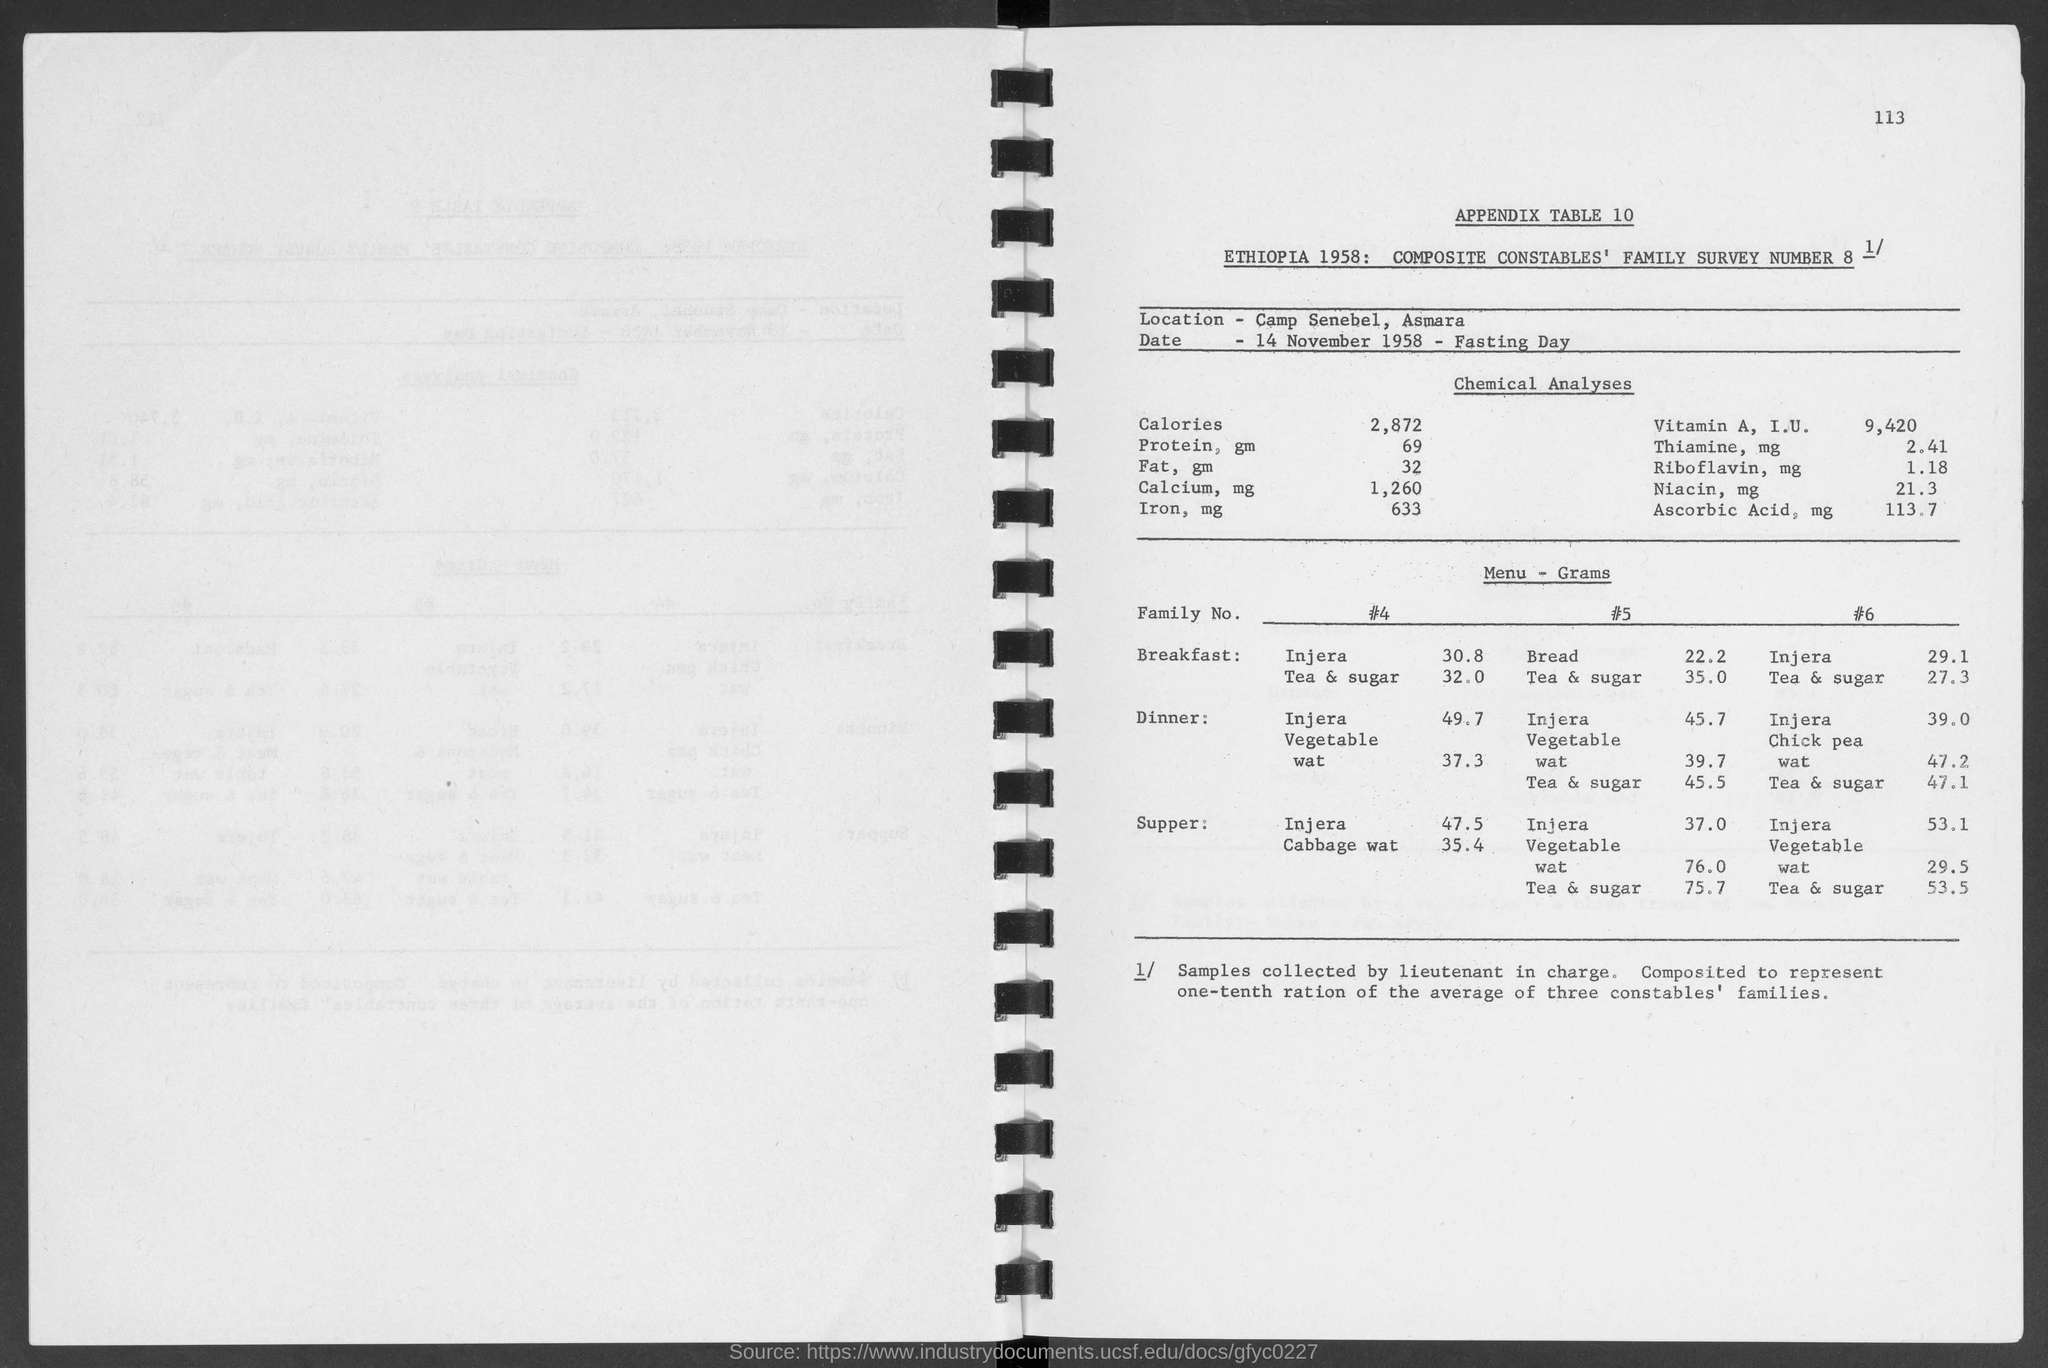Give some essential details in this illustration. The amount of Calcium in the chemical analysis is 1,260 milligrams. The amount of iron, measured in milligrams (mg), in a chemical analysis is 633 mg. The number at the top-right corner of the page is 113. A chemical analysis indicates that there is 2.41 milligrams of Thiamine present in the given amount. Appendix table number is [insert appendix table number]. The appendix table is [insert appendix table description]. 